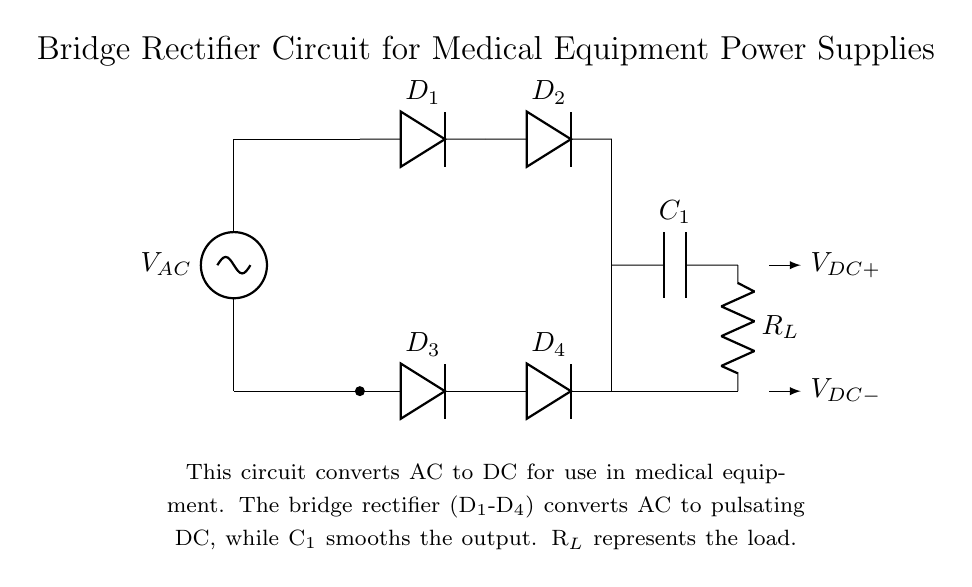What components make up the bridge rectifier? The bridge rectifier in this circuit consists of four diodes labeled D1, D2, D3, and D4, which are arranged in a bridge configuration to convert AC to DC.
Answer: D1, D2, D3, D4 What does the capacitor C1 do in this circuit? Capacitor C1 acts as a smoothing component that reduces the ripple in the output voltage after the rectification process, providing a more stable DC output for medical equipment.
Answer: Smoothes DC output What is the function of the load resistor R_L? The load resistor R_L represents the component or device that utilizes the DC voltage output from the rectifier circuit, simulating the actual load in medical equipment.
Answer: Represents load How many diodes are present in the bridge rectifier circuit? There are four diodes present as part of the bridge rectifier, functioning to allow current to flow in both directions during the AC cycles.
Answer: Four What is the output voltage polarity in this rectifier circuit? The output voltage polarity indicates that the top terminal connected to the load resistor (V_DC+) is positive, while the bottom terminal (V_DC-) is negative, meaning the circuit provides a DC output.
Answer: Positive and negative What type of current does this circuit convert? The circuit converts alternating current (AC) into direct current (DC) suitable for powering medical devices that require a stable voltage.
Answer: Alternating current 